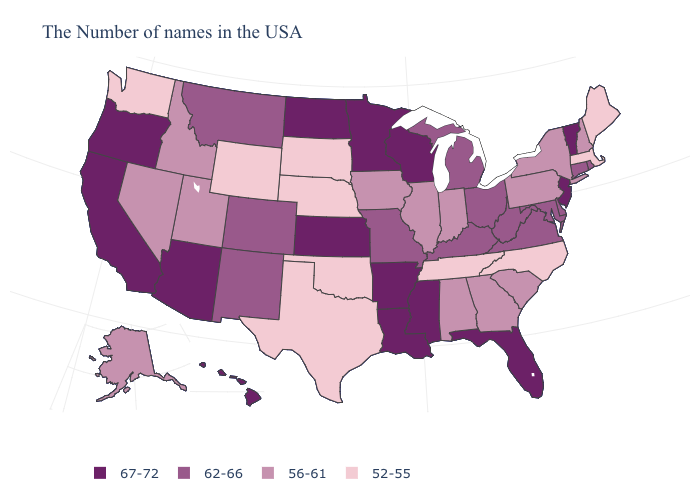Name the states that have a value in the range 56-61?
Concise answer only. New Hampshire, New York, Pennsylvania, South Carolina, Georgia, Indiana, Alabama, Illinois, Iowa, Utah, Idaho, Nevada, Alaska. What is the value of New Jersey?
Quick response, please. 67-72. What is the highest value in the South ?
Short answer required. 67-72. Name the states that have a value in the range 52-55?
Answer briefly. Maine, Massachusetts, North Carolina, Tennessee, Nebraska, Oklahoma, Texas, South Dakota, Wyoming, Washington. Which states have the lowest value in the USA?
Keep it brief. Maine, Massachusetts, North Carolina, Tennessee, Nebraska, Oklahoma, Texas, South Dakota, Wyoming, Washington. Among the states that border Pennsylvania , does New Jersey have the highest value?
Short answer required. Yes. Does the map have missing data?
Quick response, please. No. Among the states that border Tennessee , which have the lowest value?
Concise answer only. North Carolina. Which states hav the highest value in the South?
Answer briefly. Florida, Mississippi, Louisiana, Arkansas. Which states have the lowest value in the South?
Short answer required. North Carolina, Tennessee, Oklahoma, Texas. Name the states that have a value in the range 67-72?
Short answer required. Vermont, New Jersey, Florida, Wisconsin, Mississippi, Louisiana, Arkansas, Minnesota, Kansas, North Dakota, Arizona, California, Oregon, Hawaii. Name the states that have a value in the range 67-72?
Concise answer only. Vermont, New Jersey, Florida, Wisconsin, Mississippi, Louisiana, Arkansas, Minnesota, Kansas, North Dakota, Arizona, California, Oregon, Hawaii. Name the states that have a value in the range 67-72?
Short answer required. Vermont, New Jersey, Florida, Wisconsin, Mississippi, Louisiana, Arkansas, Minnesota, Kansas, North Dakota, Arizona, California, Oregon, Hawaii. Does Georgia have a higher value than Utah?
Short answer required. No. What is the value of Iowa?
Answer briefly. 56-61. 